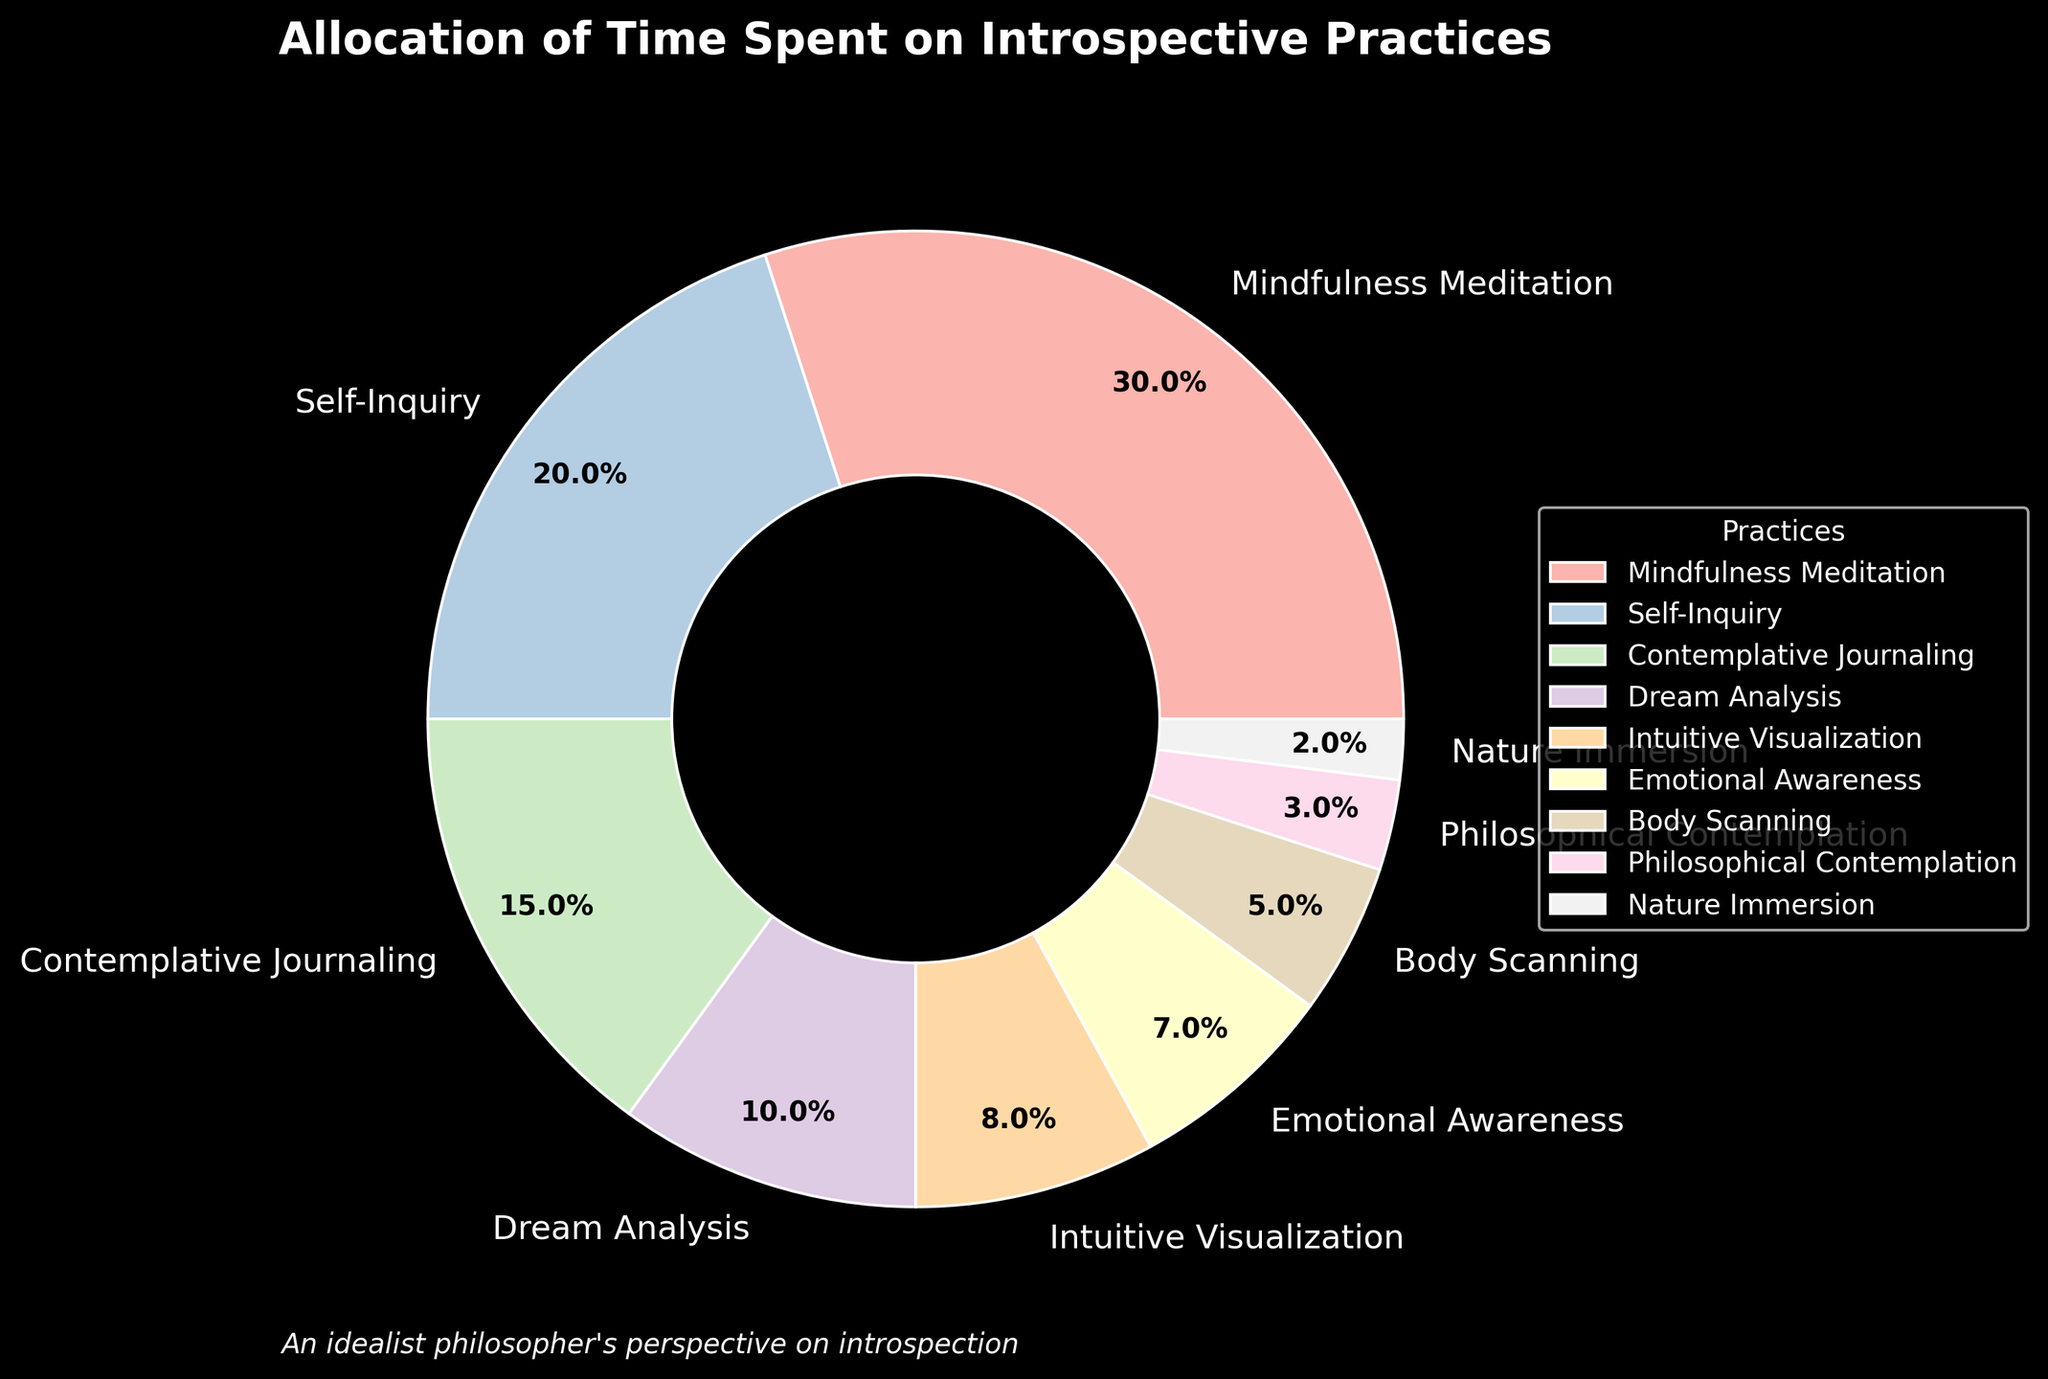What percentage is allocated to Meditation Practice excluding Mindfulness Meditation and Self-Inquiry? Exclude the percentages of Mindfulness Meditation (30%) and Self-Inquiry (20%) from the total 100%. The remaining percentage is 100% - 30% - 20% = 50%.
Answer: 50% Which practice segment is the smallest in the pie chart? Nature Immersion, as it has the smallest slice allocated at 2%.
Answer: Nature Immersion How much more time is spent on Intuitive Visualization compared to Body Scanning? Check the respective percentages: Intuitive Visualization (8%) and Body Scanning (5%). The difference is 8% - 5% = 3%.
Answer: 3% Which practice has a larger allocation, Emotional Awareness or Dream Analysis? Compare the percentages: Emotional Awareness (7%) and Dream Analysis (10%). Dream Analysis has a larger allocation.
Answer: Dream Analysis How many practices have a percentage allocation of 10% or more? Identify the practices: Mindfulness Meditation (30%), Self-Inquiry (20%), and Dream Analysis (10%). There are 3 practices.
Answer: 3 By how much does Contemplative Journaling exceed the allocation of Body Scanning? Compare the respective percentages: Contemplative Journaling (15%) and Body Scanning (5%). The excess is 15% - 5% = 10%.
Answer: 10% What is the total percentage allocation of practices less than 10%? Sum the percentages of Dream Analysis (10%), Intuitive Visualization (8%), Emotional Awareness (7%), Body Scanning (5%), Philosophical Contemplation (3%), and Nature Immersion (2%). Total = 10 + 8 + 7 + 5 + 3 + 2 = 35%.
Answer: 35% How does the percentage allocation for Emotional Awareness compare visually to Body Scanning? Emotional Awareness has a larger slice (7%) compared to Body Scanning (5%). Visually, the segment for Emotional Awareness is wider.
Answer: Emotional Awareness has a larger slice What is the combined percentage for practices with less than 5% allocation? Only Nature Immersion (2%) falls into this category, so the total is 2%.
Answer: 2% Which practices combined exactly equal the allocation of Self-Inquiry? Identify the practices whose combined percentage matches 20%: Contemplative Journaling (15%) + Body Scanning (5%).
Answer: Contemplative Journaling and Body Scanning 